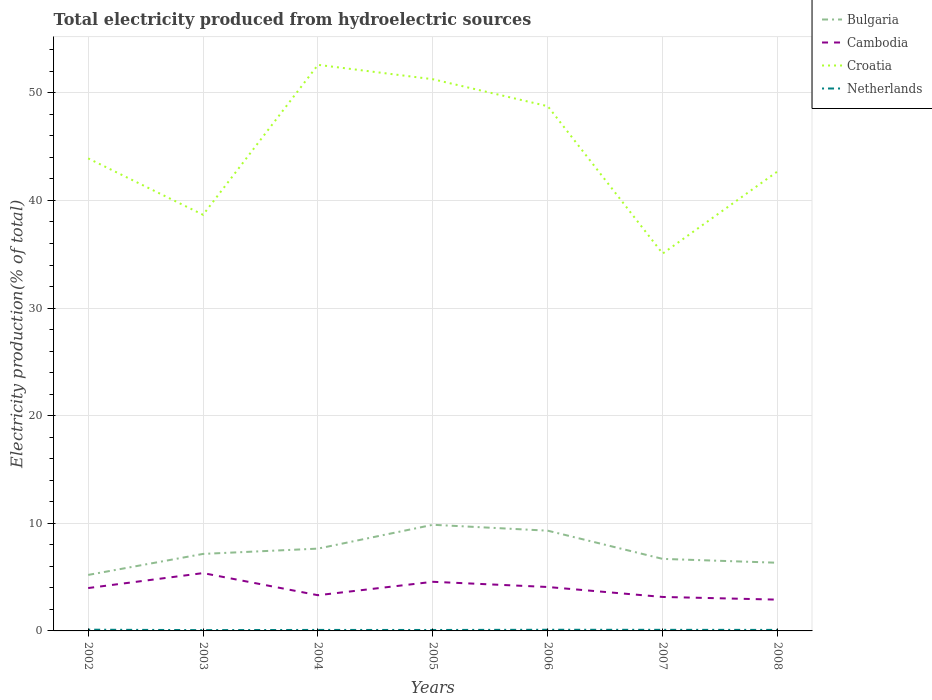How many different coloured lines are there?
Offer a very short reply. 4. Does the line corresponding to Croatia intersect with the line corresponding to Cambodia?
Offer a very short reply. No. Across all years, what is the maximum total electricity produced in Netherlands?
Your answer should be very brief. 0.07. What is the total total electricity produced in Netherlands in the graph?
Provide a short and direct response. 0.01. What is the difference between the highest and the second highest total electricity produced in Bulgaria?
Your answer should be very brief. 4.66. What is the difference between the highest and the lowest total electricity produced in Netherlands?
Make the answer very short. 3. How many lines are there?
Offer a terse response. 4. How many years are there in the graph?
Make the answer very short. 7. Does the graph contain any zero values?
Your response must be concise. No. How many legend labels are there?
Your answer should be compact. 4. What is the title of the graph?
Give a very brief answer. Total electricity produced from hydroelectric sources. What is the label or title of the X-axis?
Give a very brief answer. Years. What is the Electricity production(% of total) in Bulgaria in 2002?
Provide a succinct answer. 5.2. What is the Electricity production(% of total) in Cambodia in 2002?
Offer a terse response. 3.98. What is the Electricity production(% of total) of Croatia in 2002?
Keep it short and to the point. 43.91. What is the Electricity production(% of total) of Netherlands in 2002?
Your answer should be compact. 0.11. What is the Electricity production(% of total) of Bulgaria in 2003?
Your response must be concise. 7.16. What is the Electricity production(% of total) in Cambodia in 2003?
Give a very brief answer. 5.37. What is the Electricity production(% of total) of Croatia in 2003?
Provide a succinct answer. 38.67. What is the Electricity production(% of total) in Netherlands in 2003?
Offer a very short reply. 0.07. What is the Electricity production(% of total) in Bulgaria in 2004?
Offer a very short reply. 7.65. What is the Electricity production(% of total) in Cambodia in 2004?
Your response must be concise. 3.32. What is the Electricity production(% of total) of Croatia in 2004?
Your response must be concise. 52.6. What is the Electricity production(% of total) of Netherlands in 2004?
Ensure brevity in your answer.  0.09. What is the Electricity production(% of total) in Bulgaria in 2005?
Offer a terse response. 9.86. What is the Electricity production(% of total) in Cambodia in 2005?
Offer a terse response. 4.56. What is the Electricity production(% of total) in Croatia in 2005?
Offer a very short reply. 51.26. What is the Electricity production(% of total) in Netherlands in 2005?
Ensure brevity in your answer.  0.09. What is the Electricity production(% of total) in Bulgaria in 2006?
Your response must be concise. 9.31. What is the Electricity production(% of total) of Cambodia in 2006?
Provide a succinct answer. 4.08. What is the Electricity production(% of total) in Croatia in 2006?
Offer a very short reply. 48.76. What is the Electricity production(% of total) of Netherlands in 2006?
Ensure brevity in your answer.  0.11. What is the Electricity production(% of total) in Bulgaria in 2007?
Make the answer very short. 6.69. What is the Electricity production(% of total) in Cambodia in 2007?
Provide a succinct answer. 3.16. What is the Electricity production(% of total) in Croatia in 2007?
Your answer should be compact. 35.06. What is the Electricity production(% of total) of Netherlands in 2007?
Ensure brevity in your answer.  0.1. What is the Electricity production(% of total) of Bulgaria in 2008?
Provide a succinct answer. 6.33. What is the Electricity production(% of total) in Cambodia in 2008?
Your response must be concise. 2.91. What is the Electricity production(% of total) of Croatia in 2008?
Offer a terse response. 42.7. What is the Electricity production(% of total) of Netherlands in 2008?
Give a very brief answer. 0.09. Across all years, what is the maximum Electricity production(% of total) in Bulgaria?
Your response must be concise. 9.86. Across all years, what is the maximum Electricity production(% of total) in Cambodia?
Provide a short and direct response. 5.37. Across all years, what is the maximum Electricity production(% of total) of Croatia?
Ensure brevity in your answer.  52.6. Across all years, what is the maximum Electricity production(% of total) of Netherlands?
Give a very brief answer. 0.11. Across all years, what is the minimum Electricity production(% of total) of Bulgaria?
Ensure brevity in your answer.  5.2. Across all years, what is the minimum Electricity production(% of total) in Cambodia?
Provide a succinct answer. 2.91. Across all years, what is the minimum Electricity production(% of total) in Croatia?
Your answer should be compact. 35.06. Across all years, what is the minimum Electricity production(% of total) of Netherlands?
Make the answer very short. 0.07. What is the total Electricity production(% of total) of Bulgaria in the graph?
Provide a short and direct response. 52.21. What is the total Electricity production(% of total) of Cambodia in the graph?
Your answer should be compact. 27.38. What is the total Electricity production(% of total) of Croatia in the graph?
Offer a terse response. 312.96. What is the total Electricity production(% of total) of Netherlands in the graph?
Your answer should be compact. 0.67. What is the difference between the Electricity production(% of total) of Bulgaria in 2002 and that in 2003?
Provide a short and direct response. -1.95. What is the difference between the Electricity production(% of total) of Cambodia in 2002 and that in 2003?
Offer a terse response. -1.39. What is the difference between the Electricity production(% of total) in Croatia in 2002 and that in 2003?
Make the answer very short. 5.24. What is the difference between the Electricity production(% of total) in Netherlands in 2002 and that in 2003?
Provide a short and direct response. 0.04. What is the difference between the Electricity production(% of total) in Bulgaria in 2002 and that in 2004?
Offer a very short reply. -2.44. What is the difference between the Electricity production(% of total) of Cambodia in 2002 and that in 2004?
Keep it short and to the point. 0.67. What is the difference between the Electricity production(% of total) in Croatia in 2002 and that in 2004?
Ensure brevity in your answer.  -8.69. What is the difference between the Electricity production(% of total) of Netherlands in 2002 and that in 2004?
Keep it short and to the point. 0.02. What is the difference between the Electricity production(% of total) of Bulgaria in 2002 and that in 2005?
Offer a terse response. -4.66. What is the difference between the Electricity production(% of total) in Cambodia in 2002 and that in 2005?
Ensure brevity in your answer.  -0.58. What is the difference between the Electricity production(% of total) of Croatia in 2002 and that in 2005?
Your answer should be compact. -7.36. What is the difference between the Electricity production(% of total) in Netherlands in 2002 and that in 2005?
Make the answer very short. 0.03. What is the difference between the Electricity production(% of total) in Bulgaria in 2002 and that in 2006?
Your answer should be very brief. -4.11. What is the difference between the Electricity production(% of total) in Cambodia in 2002 and that in 2006?
Give a very brief answer. -0.1. What is the difference between the Electricity production(% of total) of Croatia in 2002 and that in 2006?
Provide a succinct answer. -4.85. What is the difference between the Electricity production(% of total) of Netherlands in 2002 and that in 2006?
Keep it short and to the point. 0.01. What is the difference between the Electricity production(% of total) of Bulgaria in 2002 and that in 2007?
Make the answer very short. -1.49. What is the difference between the Electricity production(% of total) of Cambodia in 2002 and that in 2007?
Offer a very short reply. 0.83. What is the difference between the Electricity production(% of total) of Croatia in 2002 and that in 2007?
Your answer should be very brief. 8.84. What is the difference between the Electricity production(% of total) in Netherlands in 2002 and that in 2007?
Give a very brief answer. 0.01. What is the difference between the Electricity production(% of total) in Bulgaria in 2002 and that in 2008?
Your answer should be compact. -1.13. What is the difference between the Electricity production(% of total) of Cambodia in 2002 and that in 2008?
Provide a succinct answer. 1.08. What is the difference between the Electricity production(% of total) of Croatia in 2002 and that in 2008?
Keep it short and to the point. 1.21. What is the difference between the Electricity production(% of total) of Netherlands in 2002 and that in 2008?
Keep it short and to the point. 0.02. What is the difference between the Electricity production(% of total) in Bulgaria in 2003 and that in 2004?
Your answer should be compact. -0.49. What is the difference between the Electricity production(% of total) in Cambodia in 2003 and that in 2004?
Your answer should be very brief. 2.06. What is the difference between the Electricity production(% of total) of Croatia in 2003 and that in 2004?
Offer a terse response. -13.93. What is the difference between the Electricity production(% of total) in Netherlands in 2003 and that in 2004?
Your response must be concise. -0.02. What is the difference between the Electricity production(% of total) in Bulgaria in 2003 and that in 2005?
Make the answer very short. -2.71. What is the difference between the Electricity production(% of total) in Cambodia in 2003 and that in 2005?
Keep it short and to the point. 0.81. What is the difference between the Electricity production(% of total) in Croatia in 2003 and that in 2005?
Provide a succinct answer. -12.6. What is the difference between the Electricity production(% of total) of Netherlands in 2003 and that in 2005?
Your answer should be compact. -0.01. What is the difference between the Electricity production(% of total) in Bulgaria in 2003 and that in 2006?
Provide a succinct answer. -2.16. What is the difference between the Electricity production(% of total) of Cambodia in 2003 and that in 2006?
Your answer should be compact. 1.29. What is the difference between the Electricity production(% of total) of Croatia in 2003 and that in 2006?
Your answer should be very brief. -10.09. What is the difference between the Electricity production(% of total) in Netherlands in 2003 and that in 2006?
Keep it short and to the point. -0.03. What is the difference between the Electricity production(% of total) of Bulgaria in 2003 and that in 2007?
Make the answer very short. 0.46. What is the difference between the Electricity production(% of total) of Cambodia in 2003 and that in 2007?
Provide a succinct answer. 2.22. What is the difference between the Electricity production(% of total) of Croatia in 2003 and that in 2007?
Give a very brief answer. 3.6. What is the difference between the Electricity production(% of total) of Netherlands in 2003 and that in 2007?
Your answer should be very brief. -0.03. What is the difference between the Electricity production(% of total) in Bulgaria in 2003 and that in 2008?
Provide a short and direct response. 0.82. What is the difference between the Electricity production(% of total) of Cambodia in 2003 and that in 2008?
Your response must be concise. 2.47. What is the difference between the Electricity production(% of total) in Croatia in 2003 and that in 2008?
Offer a terse response. -4.03. What is the difference between the Electricity production(% of total) in Netherlands in 2003 and that in 2008?
Give a very brief answer. -0.02. What is the difference between the Electricity production(% of total) in Bulgaria in 2004 and that in 2005?
Your answer should be very brief. -2.22. What is the difference between the Electricity production(% of total) in Cambodia in 2004 and that in 2005?
Your answer should be very brief. -1.25. What is the difference between the Electricity production(% of total) of Croatia in 2004 and that in 2005?
Provide a succinct answer. 1.34. What is the difference between the Electricity production(% of total) in Netherlands in 2004 and that in 2005?
Your answer should be very brief. 0. What is the difference between the Electricity production(% of total) of Bulgaria in 2004 and that in 2006?
Your response must be concise. -1.67. What is the difference between the Electricity production(% of total) in Cambodia in 2004 and that in 2006?
Make the answer very short. -0.76. What is the difference between the Electricity production(% of total) of Croatia in 2004 and that in 2006?
Keep it short and to the point. 3.84. What is the difference between the Electricity production(% of total) of Netherlands in 2004 and that in 2006?
Your answer should be compact. -0.01. What is the difference between the Electricity production(% of total) of Bulgaria in 2004 and that in 2007?
Provide a short and direct response. 0.95. What is the difference between the Electricity production(% of total) in Cambodia in 2004 and that in 2007?
Offer a terse response. 0.16. What is the difference between the Electricity production(% of total) of Croatia in 2004 and that in 2007?
Keep it short and to the point. 17.54. What is the difference between the Electricity production(% of total) in Netherlands in 2004 and that in 2007?
Your answer should be compact. -0.01. What is the difference between the Electricity production(% of total) in Bulgaria in 2004 and that in 2008?
Ensure brevity in your answer.  1.31. What is the difference between the Electricity production(% of total) of Cambodia in 2004 and that in 2008?
Provide a short and direct response. 0.41. What is the difference between the Electricity production(% of total) of Croatia in 2004 and that in 2008?
Provide a succinct answer. 9.9. What is the difference between the Electricity production(% of total) in Netherlands in 2004 and that in 2008?
Your response must be concise. -0. What is the difference between the Electricity production(% of total) of Bulgaria in 2005 and that in 2006?
Make the answer very short. 0.55. What is the difference between the Electricity production(% of total) in Cambodia in 2005 and that in 2006?
Your response must be concise. 0.48. What is the difference between the Electricity production(% of total) in Croatia in 2005 and that in 2006?
Give a very brief answer. 2.51. What is the difference between the Electricity production(% of total) in Netherlands in 2005 and that in 2006?
Keep it short and to the point. -0.02. What is the difference between the Electricity production(% of total) of Bulgaria in 2005 and that in 2007?
Your answer should be compact. 3.17. What is the difference between the Electricity production(% of total) in Cambodia in 2005 and that in 2007?
Your answer should be very brief. 1.41. What is the difference between the Electricity production(% of total) of Croatia in 2005 and that in 2007?
Your answer should be compact. 16.2. What is the difference between the Electricity production(% of total) in Netherlands in 2005 and that in 2007?
Give a very brief answer. -0.01. What is the difference between the Electricity production(% of total) in Bulgaria in 2005 and that in 2008?
Give a very brief answer. 3.53. What is the difference between the Electricity production(% of total) in Cambodia in 2005 and that in 2008?
Your answer should be compact. 1.66. What is the difference between the Electricity production(% of total) of Croatia in 2005 and that in 2008?
Make the answer very short. 8.56. What is the difference between the Electricity production(% of total) in Netherlands in 2005 and that in 2008?
Ensure brevity in your answer.  -0.01. What is the difference between the Electricity production(% of total) in Bulgaria in 2006 and that in 2007?
Offer a terse response. 2.62. What is the difference between the Electricity production(% of total) in Cambodia in 2006 and that in 2007?
Ensure brevity in your answer.  0.93. What is the difference between the Electricity production(% of total) in Croatia in 2006 and that in 2007?
Offer a terse response. 13.69. What is the difference between the Electricity production(% of total) of Netherlands in 2006 and that in 2007?
Offer a terse response. 0.01. What is the difference between the Electricity production(% of total) in Bulgaria in 2006 and that in 2008?
Offer a very short reply. 2.98. What is the difference between the Electricity production(% of total) in Cambodia in 2006 and that in 2008?
Offer a terse response. 1.17. What is the difference between the Electricity production(% of total) of Croatia in 2006 and that in 2008?
Provide a succinct answer. 6.06. What is the difference between the Electricity production(% of total) in Netherlands in 2006 and that in 2008?
Provide a short and direct response. 0.01. What is the difference between the Electricity production(% of total) in Bulgaria in 2007 and that in 2008?
Make the answer very short. 0.36. What is the difference between the Electricity production(% of total) in Cambodia in 2007 and that in 2008?
Your response must be concise. 0.25. What is the difference between the Electricity production(% of total) of Croatia in 2007 and that in 2008?
Keep it short and to the point. -7.63. What is the difference between the Electricity production(% of total) of Netherlands in 2007 and that in 2008?
Offer a very short reply. 0.01. What is the difference between the Electricity production(% of total) of Bulgaria in 2002 and the Electricity production(% of total) of Cambodia in 2003?
Your response must be concise. -0.17. What is the difference between the Electricity production(% of total) of Bulgaria in 2002 and the Electricity production(% of total) of Croatia in 2003?
Offer a very short reply. -33.46. What is the difference between the Electricity production(% of total) of Bulgaria in 2002 and the Electricity production(% of total) of Netherlands in 2003?
Your answer should be very brief. 5.13. What is the difference between the Electricity production(% of total) of Cambodia in 2002 and the Electricity production(% of total) of Croatia in 2003?
Ensure brevity in your answer.  -34.68. What is the difference between the Electricity production(% of total) in Cambodia in 2002 and the Electricity production(% of total) in Netherlands in 2003?
Make the answer very short. 3.91. What is the difference between the Electricity production(% of total) of Croatia in 2002 and the Electricity production(% of total) of Netherlands in 2003?
Keep it short and to the point. 43.83. What is the difference between the Electricity production(% of total) in Bulgaria in 2002 and the Electricity production(% of total) in Cambodia in 2004?
Give a very brief answer. 1.89. What is the difference between the Electricity production(% of total) of Bulgaria in 2002 and the Electricity production(% of total) of Croatia in 2004?
Your response must be concise. -47.4. What is the difference between the Electricity production(% of total) in Bulgaria in 2002 and the Electricity production(% of total) in Netherlands in 2004?
Offer a terse response. 5.11. What is the difference between the Electricity production(% of total) in Cambodia in 2002 and the Electricity production(% of total) in Croatia in 2004?
Provide a succinct answer. -48.62. What is the difference between the Electricity production(% of total) in Cambodia in 2002 and the Electricity production(% of total) in Netherlands in 2004?
Offer a very short reply. 3.89. What is the difference between the Electricity production(% of total) in Croatia in 2002 and the Electricity production(% of total) in Netherlands in 2004?
Your answer should be compact. 43.81. What is the difference between the Electricity production(% of total) in Bulgaria in 2002 and the Electricity production(% of total) in Cambodia in 2005?
Your response must be concise. 0.64. What is the difference between the Electricity production(% of total) of Bulgaria in 2002 and the Electricity production(% of total) of Croatia in 2005?
Offer a very short reply. -46.06. What is the difference between the Electricity production(% of total) in Bulgaria in 2002 and the Electricity production(% of total) in Netherlands in 2005?
Your answer should be very brief. 5.12. What is the difference between the Electricity production(% of total) in Cambodia in 2002 and the Electricity production(% of total) in Croatia in 2005?
Give a very brief answer. -47.28. What is the difference between the Electricity production(% of total) in Cambodia in 2002 and the Electricity production(% of total) in Netherlands in 2005?
Provide a short and direct response. 3.9. What is the difference between the Electricity production(% of total) of Croatia in 2002 and the Electricity production(% of total) of Netherlands in 2005?
Ensure brevity in your answer.  43.82. What is the difference between the Electricity production(% of total) of Bulgaria in 2002 and the Electricity production(% of total) of Cambodia in 2006?
Ensure brevity in your answer.  1.12. What is the difference between the Electricity production(% of total) in Bulgaria in 2002 and the Electricity production(% of total) in Croatia in 2006?
Your answer should be very brief. -43.55. What is the difference between the Electricity production(% of total) of Bulgaria in 2002 and the Electricity production(% of total) of Netherlands in 2006?
Make the answer very short. 5.1. What is the difference between the Electricity production(% of total) of Cambodia in 2002 and the Electricity production(% of total) of Croatia in 2006?
Your response must be concise. -44.77. What is the difference between the Electricity production(% of total) in Cambodia in 2002 and the Electricity production(% of total) in Netherlands in 2006?
Your answer should be very brief. 3.88. What is the difference between the Electricity production(% of total) in Croatia in 2002 and the Electricity production(% of total) in Netherlands in 2006?
Your answer should be compact. 43.8. What is the difference between the Electricity production(% of total) of Bulgaria in 2002 and the Electricity production(% of total) of Cambodia in 2007?
Your response must be concise. 2.05. What is the difference between the Electricity production(% of total) in Bulgaria in 2002 and the Electricity production(% of total) in Croatia in 2007?
Provide a succinct answer. -29.86. What is the difference between the Electricity production(% of total) of Bulgaria in 2002 and the Electricity production(% of total) of Netherlands in 2007?
Your answer should be very brief. 5.1. What is the difference between the Electricity production(% of total) of Cambodia in 2002 and the Electricity production(% of total) of Croatia in 2007?
Make the answer very short. -31.08. What is the difference between the Electricity production(% of total) in Cambodia in 2002 and the Electricity production(% of total) in Netherlands in 2007?
Your answer should be very brief. 3.88. What is the difference between the Electricity production(% of total) in Croatia in 2002 and the Electricity production(% of total) in Netherlands in 2007?
Your answer should be very brief. 43.81. What is the difference between the Electricity production(% of total) in Bulgaria in 2002 and the Electricity production(% of total) in Cambodia in 2008?
Ensure brevity in your answer.  2.3. What is the difference between the Electricity production(% of total) in Bulgaria in 2002 and the Electricity production(% of total) in Croatia in 2008?
Your answer should be very brief. -37.5. What is the difference between the Electricity production(% of total) in Bulgaria in 2002 and the Electricity production(% of total) in Netherlands in 2008?
Make the answer very short. 5.11. What is the difference between the Electricity production(% of total) in Cambodia in 2002 and the Electricity production(% of total) in Croatia in 2008?
Offer a terse response. -38.71. What is the difference between the Electricity production(% of total) of Cambodia in 2002 and the Electricity production(% of total) of Netherlands in 2008?
Offer a very short reply. 3.89. What is the difference between the Electricity production(% of total) in Croatia in 2002 and the Electricity production(% of total) in Netherlands in 2008?
Give a very brief answer. 43.81. What is the difference between the Electricity production(% of total) in Bulgaria in 2003 and the Electricity production(% of total) in Cambodia in 2004?
Offer a terse response. 3.84. What is the difference between the Electricity production(% of total) in Bulgaria in 2003 and the Electricity production(% of total) in Croatia in 2004?
Provide a short and direct response. -45.44. What is the difference between the Electricity production(% of total) in Bulgaria in 2003 and the Electricity production(% of total) in Netherlands in 2004?
Keep it short and to the point. 7.06. What is the difference between the Electricity production(% of total) in Cambodia in 2003 and the Electricity production(% of total) in Croatia in 2004?
Provide a short and direct response. -47.23. What is the difference between the Electricity production(% of total) of Cambodia in 2003 and the Electricity production(% of total) of Netherlands in 2004?
Make the answer very short. 5.28. What is the difference between the Electricity production(% of total) of Croatia in 2003 and the Electricity production(% of total) of Netherlands in 2004?
Ensure brevity in your answer.  38.58. What is the difference between the Electricity production(% of total) in Bulgaria in 2003 and the Electricity production(% of total) in Cambodia in 2005?
Make the answer very short. 2.59. What is the difference between the Electricity production(% of total) in Bulgaria in 2003 and the Electricity production(% of total) in Croatia in 2005?
Your answer should be very brief. -44.11. What is the difference between the Electricity production(% of total) in Bulgaria in 2003 and the Electricity production(% of total) in Netherlands in 2005?
Give a very brief answer. 7.07. What is the difference between the Electricity production(% of total) of Cambodia in 2003 and the Electricity production(% of total) of Croatia in 2005?
Ensure brevity in your answer.  -45.89. What is the difference between the Electricity production(% of total) of Cambodia in 2003 and the Electricity production(% of total) of Netherlands in 2005?
Ensure brevity in your answer.  5.29. What is the difference between the Electricity production(% of total) of Croatia in 2003 and the Electricity production(% of total) of Netherlands in 2005?
Your answer should be very brief. 38.58. What is the difference between the Electricity production(% of total) of Bulgaria in 2003 and the Electricity production(% of total) of Cambodia in 2006?
Ensure brevity in your answer.  3.07. What is the difference between the Electricity production(% of total) of Bulgaria in 2003 and the Electricity production(% of total) of Croatia in 2006?
Keep it short and to the point. -41.6. What is the difference between the Electricity production(% of total) of Bulgaria in 2003 and the Electricity production(% of total) of Netherlands in 2006?
Keep it short and to the point. 7.05. What is the difference between the Electricity production(% of total) in Cambodia in 2003 and the Electricity production(% of total) in Croatia in 2006?
Give a very brief answer. -43.38. What is the difference between the Electricity production(% of total) of Cambodia in 2003 and the Electricity production(% of total) of Netherlands in 2006?
Offer a terse response. 5.27. What is the difference between the Electricity production(% of total) in Croatia in 2003 and the Electricity production(% of total) in Netherlands in 2006?
Your answer should be very brief. 38.56. What is the difference between the Electricity production(% of total) in Bulgaria in 2003 and the Electricity production(% of total) in Cambodia in 2007?
Your answer should be compact. 4. What is the difference between the Electricity production(% of total) of Bulgaria in 2003 and the Electricity production(% of total) of Croatia in 2007?
Your answer should be compact. -27.91. What is the difference between the Electricity production(% of total) in Bulgaria in 2003 and the Electricity production(% of total) in Netherlands in 2007?
Offer a very short reply. 7.05. What is the difference between the Electricity production(% of total) in Cambodia in 2003 and the Electricity production(% of total) in Croatia in 2007?
Provide a short and direct response. -29.69. What is the difference between the Electricity production(% of total) in Cambodia in 2003 and the Electricity production(% of total) in Netherlands in 2007?
Keep it short and to the point. 5.27. What is the difference between the Electricity production(% of total) of Croatia in 2003 and the Electricity production(% of total) of Netherlands in 2007?
Provide a short and direct response. 38.57. What is the difference between the Electricity production(% of total) in Bulgaria in 2003 and the Electricity production(% of total) in Cambodia in 2008?
Keep it short and to the point. 4.25. What is the difference between the Electricity production(% of total) in Bulgaria in 2003 and the Electricity production(% of total) in Croatia in 2008?
Ensure brevity in your answer.  -35.54. What is the difference between the Electricity production(% of total) of Bulgaria in 2003 and the Electricity production(% of total) of Netherlands in 2008?
Give a very brief answer. 7.06. What is the difference between the Electricity production(% of total) in Cambodia in 2003 and the Electricity production(% of total) in Croatia in 2008?
Your answer should be compact. -37.32. What is the difference between the Electricity production(% of total) of Cambodia in 2003 and the Electricity production(% of total) of Netherlands in 2008?
Keep it short and to the point. 5.28. What is the difference between the Electricity production(% of total) of Croatia in 2003 and the Electricity production(% of total) of Netherlands in 2008?
Provide a succinct answer. 38.57. What is the difference between the Electricity production(% of total) in Bulgaria in 2004 and the Electricity production(% of total) in Cambodia in 2005?
Offer a terse response. 3.08. What is the difference between the Electricity production(% of total) in Bulgaria in 2004 and the Electricity production(% of total) in Croatia in 2005?
Your response must be concise. -43.62. What is the difference between the Electricity production(% of total) in Bulgaria in 2004 and the Electricity production(% of total) in Netherlands in 2005?
Your answer should be very brief. 7.56. What is the difference between the Electricity production(% of total) of Cambodia in 2004 and the Electricity production(% of total) of Croatia in 2005?
Give a very brief answer. -47.95. What is the difference between the Electricity production(% of total) in Cambodia in 2004 and the Electricity production(% of total) in Netherlands in 2005?
Keep it short and to the point. 3.23. What is the difference between the Electricity production(% of total) of Croatia in 2004 and the Electricity production(% of total) of Netherlands in 2005?
Your answer should be compact. 52.51. What is the difference between the Electricity production(% of total) in Bulgaria in 2004 and the Electricity production(% of total) in Cambodia in 2006?
Provide a succinct answer. 3.57. What is the difference between the Electricity production(% of total) in Bulgaria in 2004 and the Electricity production(% of total) in Croatia in 2006?
Offer a very short reply. -41.11. What is the difference between the Electricity production(% of total) in Bulgaria in 2004 and the Electricity production(% of total) in Netherlands in 2006?
Make the answer very short. 7.54. What is the difference between the Electricity production(% of total) of Cambodia in 2004 and the Electricity production(% of total) of Croatia in 2006?
Offer a very short reply. -45.44. What is the difference between the Electricity production(% of total) of Cambodia in 2004 and the Electricity production(% of total) of Netherlands in 2006?
Ensure brevity in your answer.  3.21. What is the difference between the Electricity production(% of total) in Croatia in 2004 and the Electricity production(% of total) in Netherlands in 2006?
Your response must be concise. 52.49. What is the difference between the Electricity production(% of total) in Bulgaria in 2004 and the Electricity production(% of total) in Cambodia in 2007?
Provide a short and direct response. 4.49. What is the difference between the Electricity production(% of total) of Bulgaria in 2004 and the Electricity production(% of total) of Croatia in 2007?
Ensure brevity in your answer.  -27.42. What is the difference between the Electricity production(% of total) in Bulgaria in 2004 and the Electricity production(% of total) in Netherlands in 2007?
Ensure brevity in your answer.  7.55. What is the difference between the Electricity production(% of total) of Cambodia in 2004 and the Electricity production(% of total) of Croatia in 2007?
Offer a terse response. -31.75. What is the difference between the Electricity production(% of total) of Cambodia in 2004 and the Electricity production(% of total) of Netherlands in 2007?
Give a very brief answer. 3.22. What is the difference between the Electricity production(% of total) of Croatia in 2004 and the Electricity production(% of total) of Netherlands in 2007?
Offer a very short reply. 52.5. What is the difference between the Electricity production(% of total) in Bulgaria in 2004 and the Electricity production(% of total) in Cambodia in 2008?
Your answer should be compact. 4.74. What is the difference between the Electricity production(% of total) of Bulgaria in 2004 and the Electricity production(% of total) of Croatia in 2008?
Offer a terse response. -35.05. What is the difference between the Electricity production(% of total) of Bulgaria in 2004 and the Electricity production(% of total) of Netherlands in 2008?
Your answer should be very brief. 7.55. What is the difference between the Electricity production(% of total) in Cambodia in 2004 and the Electricity production(% of total) in Croatia in 2008?
Ensure brevity in your answer.  -39.38. What is the difference between the Electricity production(% of total) of Cambodia in 2004 and the Electricity production(% of total) of Netherlands in 2008?
Your answer should be compact. 3.22. What is the difference between the Electricity production(% of total) in Croatia in 2004 and the Electricity production(% of total) in Netherlands in 2008?
Your answer should be compact. 52.51. What is the difference between the Electricity production(% of total) in Bulgaria in 2005 and the Electricity production(% of total) in Cambodia in 2006?
Make the answer very short. 5.78. What is the difference between the Electricity production(% of total) in Bulgaria in 2005 and the Electricity production(% of total) in Croatia in 2006?
Your answer should be compact. -38.89. What is the difference between the Electricity production(% of total) in Bulgaria in 2005 and the Electricity production(% of total) in Netherlands in 2006?
Give a very brief answer. 9.76. What is the difference between the Electricity production(% of total) in Cambodia in 2005 and the Electricity production(% of total) in Croatia in 2006?
Ensure brevity in your answer.  -44.19. What is the difference between the Electricity production(% of total) of Cambodia in 2005 and the Electricity production(% of total) of Netherlands in 2006?
Your response must be concise. 4.46. What is the difference between the Electricity production(% of total) in Croatia in 2005 and the Electricity production(% of total) in Netherlands in 2006?
Offer a terse response. 51.16. What is the difference between the Electricity production(% of total) in Bulgaria in 2005 and the Electricity production(% of total) in Cambodia in 2007?
Offer a terse response. 6.71. What is the difference between the Electricity production(% of total) in Bulgaria in 2005 and the Electricity production(% of total) in Croatia in 2007?
Your answer should be very brief. -25.2. What is the difference between the Electricity production(% of total) of Bulgaria in 2005 and the Electricity production(% of total) of Netherlands in 2007?
Ensure brevity in your answer.  9.76. What is the difference between the Electricity production(% of total) in Cambodia in 2005 and the Electricity production(% of total) in Croatia in 2007?
Provide a succinct answer. -30.5. What is the difference between the Electricity production(% of total) of Cambodia in 2005 and the Electricity production(% of total) of Netherlands in 2007?
Offer a terse response. 4.46. What is the difference between the Electricity production(% of total) of Croatia in 2005 and the Electricity production(% of total) of Netherlands in 2007?
Provide a succinct answer. 51.16. What is the difference between the Electricity production(% of total) of Bulgaria in 2005 and the Electricity production(% of total) of Cambodia in 2008?
Your response must be concise. 6.96. What is the difference between the Electricity production(% of total) in Bulgaria in 2005 and the Electricity production(% of total) in Croatia in 2008?
Offer a terse response. -32.84. What is the difference between the Electricity production(% of total) of Bulgaria in 2005 and the Electricity production(% of total) of Netherlands in 2008?
Make the answer very short. 9.77. What is the difference between the Electricity production(% of total) of Cambodia in 2005 and the Electricity production(% of total) of Croatia in 2008?
Provide a succinct answer. -38.13. What is the difference between the Electricity production(% of total) of Cambodia in 2005 and the Electricity production(% of total) of Netherlands in 2008?
Make the answer very short. 4.47. What is the difference between the Electricity production(% of total) in Croatia in 2005 and the Electricity production(% of total) in Netherlands in 2008?
Your response must be concise. 51.17. What is the difference between the Electricity production(% of total) of Bulgaria in 2006 and the Electricity production(% of total) of Cambodia in 2007?
Give a very brief answer. 6.16. What is the difference between the Electricity production(% of total) of Bulgaria in 2006 and the Electricity production(% of total) of Croatia in 2007?
Give a very brief answer. -25.75. What is the difference between the Electricity production(% of total) of Bulgaria in 2006 and the Electricity production(% of total) of Netherlands in 2007?
Your answer should be very brief. 9.21. What is the difference between the Electricity production(% of total) in Cambodia in 2006 and the Electricity production(% of total) in Croatia in 2007?
Keep it short and to the point. -30.98. What is the difference between the Electricity production(% of total) in Cambodia in 2006 and the Electricity production(% of total) in Netherlands in 2007?
Offer a very short reply. 3.98. What is the difference between the Electricity production(% of total) of Croatia in 2006 and the Electricity production(% of total) of Netherlands in 2007?
Provide a succinct answer. 48.66. What is the difference between the Electricity production(% of total) of Bulgaria in 2006 and the Electricity production(% of total) of Cambodia in 2008?
Make the answer very short. 6.41. What is the difference between the Electricity production(% of total) in Bulgaria in 2006 and the Electricity production(% of total) in Croatia in 2008?
Your answer should be compact. -33.38. What is the difference between the Electricity production(% of total) of Bulgaria in 2006 and the Electricity production(% of total) of Netherlands in 2008?
Your answer should be very brief. 9.22. What is the difference between the Electricity production(% of total) of Cambodia in 2006 and the Electricity production(% of total) of Croatia in 2008?
Give a very brief answer. -38.62. What is the difference between the Electricity production(% of total) of Cambodia in 2006 and the Electricity production(% of total) of Netherlands in 2008?
Offer a very short reply. 3.99. What is the difference between the Electricity production(% of total) in Croatia in 2006 and the Electricity production(% of total) in Netherlands in 2008?
Offer a terse response. 48.66. What is the difference between the Electricity production(% of total) of Bulgaria in 2007 and the Electricity production(% of total) of Cambodia in 2008?
Your answer should be compact. 3.79. What is the difference between the Electricity production(% of total) in Bulgaria in 2007 and the Electricity production(% of total) in Croatia in 2008?
Keep it short and to the point. -36. What is the difference between the Electricity production(% of total) of Bulgaria in 2007 and the Electricity production(% of total) of Netherlands in 2008?
Offer a very short reply. 6.6. What is the difference between the Electricity production(% of total) of Cambodia in 2007 and the Electricity production(% of total) of Croatia in 2008?
Give a very brief answer. -39.54. What is the difference between the Electricity production(% of total) in Cambodia in 2007 and the Electricity production(% of total) in Netherlands in 2008?
Your response must be concise. 3.06. What is the difference between the Electricity production(% of total) of Croatia in 2007 and the Electricity production(% of total) of Netherlands in 2008?
Keep it short and to the point. 34.97. What is the average Electricity production(% of total) in Bulgaria per year?
Provide a short and direct response. 7.46. What is the average Electricity production(% of total) of Cambodia per year?
Provide a succinct answer. 3.91. What is the average Electricity production(% of total) in Croatia per year?
Make the answer very short. 44.71. What is the average Electricity production(% of total) in Netherlands per year?
Ensure brevity in your answer.  0.1. In the year 2002, what is the difference between the Electricity production(% of total) in Bulgaria and Electricity production(% of total) in Cambodia?
Ensure brevity in your answer.  1.22. In the year 2002, what is the difference between the Electricity production(% of total) in Bulgaria and Electricity production(% of total) in Croatia?
Your answer should be very brief. -38.7. In the year 2002, what is the difference between the Electricity production(% of total) in Bulgaria and Electricity production(% of total) in Netherlands?
Offer a very short reply. 5.09. In the year 2002, what is the difference between the Electricity production(% of total) of Cambodia and Electricity production(% of total) of Croatia?
Provide a short and direct response. -39.92. In the year 2002, what is the difference between the Electricity production(% of total) of Cambodia and Electricity production(% of total) of Netherlands?
Your answer should be very brief. 3.87. In the year 2002, what is the difference between the Electricity production(% of total) in Croatia and Electricity production(% of total) in Netherlands?
Provide a short and direct response. 43.79. In the year 2003, what is the difference between the Electricity production(% of total) in Bulgaria and Electricity production(% of total) in Cambodia?
Ensure brevity in your answer.  1.78. In the year 2003, what is the difference between the Electricity production(% of total) in Bulgaria and Electricity production(% of total) in Croatia?
Provide a succinct answer. -31.51. In the year 2003, what is the difference between the Electricity production(% of total) in Bulgaria and Electricity production(% of total) in Netherlands?
Your response must be concise. 7.08. In the year 2003, what is the difference between the Electricity production(% of total) in Cambodia and Electricity production(% of total) in Croatia?
Make the answer very short. -33.29. In the year 2003, what is the difference between the Electricity production(% of total) of Cambodia and Electricity production(% of total) of Netherlands?
Offer a very short reply. 5.3. In the year 2003, what is the difference between the Electricity production(% of total) of Croatia and Electricity production(% of total) of Netherlands?
Your answer should be compact. 38.59. In the year 2004, what is the difference between the Electricity production(% of total) in Bulgaria and Electricity production(% of total) in Cambodia?
Your answer should be compact. 4.33. In the year 2004, what is the difference between the Electricity production(% of total) of Bulgaria and Electricity production(% of total) of Croatia?
Provide a short and direct response. -44.95. In the year 2004, what is the difference between the Electricity production(% of total) of Bulgaria and Electricity production(% of total) of Netherlands?
Your answer should be very brief. 7.55. In the year 2004, what is the difference between the Electricity production(% of total) in Cambodia and Electricity production(% of total) in Croatia?
Provide a succinct answer. -49.28. In the year 2004, what is the difference between the Electricity production(% of total) of Cambodia and Electricity production(% of total) of Netherlands?
Your answer should be very brief. 3.22. In the year 2004, what is the difference between the Electricity production(% of total) of Croatia and Electricity production(% of total) of Netherlands?
Offer a terse response. 52.51. In the year 2005, what is the difference between the Electricity production(% of total) of Bulgaria and Electricity production(% of total) of Cambodia?
Your answer should be compact. 5.3. In the year 2005, what is the difference between the Electricity production(% of total) of Bulgaria and Electricity production(% of total) of Croatia?
Your answer should be very brief. -41.4. In the year 2005, what is the difference between the Electricity production(% of total) in Bulgaria and Electricity production(% of total) in Netherlands?
Give a very brief answer. 9.78. In the year 2005, what is the difference between the Electricity production(% of total) in Cambodia and Electricity production(% of total) in Croatia?
Provide a succinct answer. -46.7. In the year 2005, what is the difference between the Electricity production(% of total) of Cambodia and Electricity production(% of total) of Netherlands?
Give a very brief answer. 4.48. In the year 2005, what is the difference between the Electricity production(% of total) of Croatia and Electricity production(% of total) of Netherlands?
Provide a short and direct response. 51.17. In the year 2006, what is the difference between the Electricity production(% of total) in Bulgaria and Electricity production(% of total) in Cambodia?
Make the answer very short. 5.23. In the year 2006, what is the difference between the Electricity production(% of total) in Bulgaria and Electricity production(% of total) in Croatia?
Provide a succinct answer. -39.44. In the year 2006, what is the difference between the Electricity production(% of total) of Bulgaria and Electricity production(% of total) of Netherlands?
Make the answer very short. 9.21. In the year 2006, what is the difference between the Electricity production(% of total) of Cambodia and Electricity production(% of total) of Croatia?
Give a very brief answer. -44.68. In the year 2006, what is the difference between the Electricity production(% of total) in Cambodia and Electricity production(% of total) in Netherlands?
Provide a succinct answer. 3.97. In the year 2006, what is the difference between the Electricity production(% of total) of Croatia and Electricity production(% of total) of Netherlands?
Make the answer very short. 48.65. In the year 2007, what is the difference between the Electricity production(% of total) in Bulgaria and Electricity production(% of total) in Cambodia?
Your answer should be very brief. 3.54. In the year 2007, what is the difference between the Electricity production(% of total) in Bulgaria and Electricity production(% of total) in Croatia?
Give a very brief answer. -28.37. In the year 2007, what is the difference between the Electricity production(% of total) of Bulgaria and Electricity production(% of total) of Netherlands?
Keep it short and to the point. 6.59. In the year 2007, what is the difference between the Electricity production(% of total) of Cambodia and Electricity production(% of total) of Croatia?
Your response must be concise. -31.91. In the year 2007, what is the difference between the Electricity production(% of total) of Cambodia and Electricity production(% of total) of Netherlands?
Provide a short and direct response. 3.05. In the year 2007, what is the difference between the Electricity production(% of total) in Croatia and Electricity production(% of total) in Netherlands?
Provide a short and direct response. 34.96. In the year 2008, what is the difference between the Electricity production(% of total) in Bulgaria and Electricity production(% of total) in Cambodia?
Provide a short and direct response. 3.43. In the year 2008, what is the difference between the Electricity production(% of total) in Bulgaria and Electricity production(% of total) in Croatia?
Offer a terse response. -36.36. In the year 2008, what is the difference between the Electricity production(% of total) of Bulgaria and Electricity production(% of total) of Netherlands?
Keep it short and to the point. 6.24. In the year 2008, what is the difference between the Electricity production(% of total) of Cambodia and Electricity production(% of total) of Croatia?
Your response must be concise. -39.79. In the year 2008, what is the difference between the Electricity production(% of total) of Cambodia and Electricity production(% of total) of Netherlands?
Give a very brief answer. 2.81. In the year 2008, what is the difference between the Electricity production(% of total) of Croatia and Electricity production(% of total) of Netherlands?
Make the answer very short. 42.6. What is the ratio of the Electricity production(% of total) in Bulgaria in 2002 to that in 2003?
Your response must be concise. 0.73. What is the ratio of the Electricity production(% of total) of Cambodia in 2002 to that in 2003?
Offer a terse response. 0.74. What is the ratio of the Electricity production(% of total) in Croatia in 2002 to that in 2003?
Your answer should be compact. 1.14. What is the ratio of the Electricity production(% of total) of Netherlands in 2002 to that in 2003?
Provide a succinct answer. 1.54. What is the ratio of the Electricity production(% of total) of Bulgaria in 2002 to that in 2004?
Give a very brief answer. 0.68. What is the ratio of the Electricity production(% of total) in Cambodia in 2002 to that in 2004?
Offer a terse response. 1.2. What is the ratio of the Electricity production(% of total) of Croatia in 2002 to that in 2004?
Keep it short and to the point. 0.83. What is the ratio of the Electricity production(% of total) in Netherlands in 2002 to that in 2004?
Your response must be concise. 1.24. What is the ratio of the Electricity production(% of total) of Bulgaria in 2002 to that in 2005?
Ensure brevity in your answer.  0.53. What is the ratio of the Electricity production(% of total) in Cambodia in 2002 to that in 2005?
Provide a short and direct response. 0.87. What is the ratio of the Electricity production(% of total) in Croatia in 2002 to that in 2005?
Give a very brief answer. 0.86. What is the ratio of the Electricity production(% of total) in Netherlands in 2002 to that in 2005?
Keep it short and to the point. 1.31. What is the ratio of the Electricity production(% of total) in Bulgaria in 2002 to that in 2006?
Keep it short and to the point. 0.56. What is the ratio of the Electricity production(% of total) in Cambodia in 2002 to that in 2006?
Offer a terse response. 0.98. What is the ratio of the Electricity production(% of total) of Croatia in 2002 to that in 2006?
Give a very brief answer. 0.9. What is the ratio of the Electricity production(% of total) in Netherlands in 2002 to that in 2006?
Make the answer very short. 1.06. What is the ratio of the Electricity production(% of total) in Bulgaria in 2002 to that in 2007?
Your answer should be compact. 0.78. What is the ratio of the Electricity production(% of total) of Cambodia in 2002 to that in 2007?
Provide a succinct answer. 1.26. What is the ratio of the Electricity production(% of total) in Croatia in 2002 to that in 2007?
Provide a short and direct response. 1.25. What is the ratio of the Electricity production(% of total) of Netherlands in 2002 to that in 2007?
Offer a terse response. 1.13. What is the ratio of the Electricity production(% of total) in Bulgaria in 2002 to that in 2008?
Provide a succinct answer. 0.82. What is the ratio of the Electricity production(% of total) of Cambodia in 2002 to that in 2008?
Keep it short and to the point. 1.37. What is the ratio of the Electricity production(% of total) in Croatia in 2002 to that in 2008?
Offer a terse response. 1.03. What is the ratio of the Electricity production(% of total) of Netherlands in 2002 to that in 2008?
Keep it short and to the point. 1.21. What is the ratio of the Electricity production(% of total) of Bulgaria in 2003 to that in 2004?
Keep it short and to the point. 0.94. What is the ratio of the Electricity production(% of total) of Cambodia in 2003 to that in 2004?
Keep it short and to the point. 1.62. What is the ratio of the Electricity production(% of total) in Croatia in 2003 to that in 2004?
Keep it short and to the point. 0.74. What is the ratio of the Electricity production(% of total) of Netherlands in 2003 to that in 2004?
Ensure brevity in your answer.  0.8. What is the ratio of the Electricity production(% of total) of Bulgaria in 2003 to that in 2005?
Your answer should be very brief. 0.73. What is the ratio of the Electricity production(% of total) of Cambodia in 2003 to that in 2005?
Give a very brief answer. 1.18. What is the ratio of the Electricity production(% of total) of Croatia in 2003 to that in 2005?
Make the answer very short. 0.75. What is the ratio of the Electricity production(% of total) in Netherlands in 2003 to that in 2005?
Keep it short and to the point. 0.85. What is the ratio of the Electricity production(% of total) in Bulgaria in 2003 to that in 2006?
Your response must be concise. 0.77. What is the ratio of the Electricity production(% of total) in Cambodia in 2003 to that in 2006?
Provide a short and direct response. 1.32. What is the ratio of the Electricity production(% of total) in Croatia in 2003 to that in 2006?
Offer a terse response. 0.79. What is the ratio of the Electricity production(% of total) of Netherlands in 2003 to that in 2006?
Make the answer very short. 0.69. What is the ratio of the Electricity production(% of total) of Bulgaria in 2003 to that in 2007?
Provide a succinct answer. 1.07. What is the ratio of the Electricity production(% of total) of Cambodia in 2003 to that in 2007?
Your answer should be very brief. 1.7. What is the ratio of the Electricity production(% of total) of Croatia in 2003 to that in 2007?
Make the answer very short. 1.1. What is the ratio of the Electricity production(% of total) in Netherlands in 2003 to that in 2007?
Your answer should be very brief. 0.73. What is the ratio of the Electricity production(% of total) in Bulgaria in 2003 to that in 2008?
Provide a short and direct response. 1.13. What is the ratio of the Electricity production(% of total) of Cambodia in 2003 to that in 2008?
Your answer should be compact. 1.85. What is the ratio of the Electricity production(% of total) in Croatia in 2003 to that in 2008?
Keep it short and to the point. 0.91. What is the ratio of the Electricity production(% of total) in Netherlands in 2003 to that in 2008?
Ensure brevity in your answer.  0.78. What is the ratio of the Electricity production(% of total) of Bulgaria in 2004 to that in 2005?
Ensure brevity in your answer.  0.78. What is the ratio of the Electricity production(% of total) of Cambodia in 2004 to that in 2005?
Keep it short and to the point. 0.73. What is the ratio of the Electricity production(% of total) in Croatia in 2004 to that in 2005?
Your response must be concise. 1.03. What is the ratio of the Electricity production(% of total) of Netherlands in 2004 to that in 2005?
Your answer should be very brief. 1.06. What is the ratio of the Electricity production(% of total) of Bulgaria in 2004 to that in 2006?
Keep it short and to the point. 0.82. What is the ratio of the Electricity production(% of total) of Cambodia in 2004 to that in 2006?
Your answer should be very brief. 0.81. What is the ratio of the Electricity production(% of total) of Croatia in 2004 to that in 2006?
Make the answer very short. 1.08. What is the ratio of the Electricity production(% of total) of Netherlands in 2004 to that in 2006?
Keep it short and to the point. 0.86. What is the ratio of the Electricity production(% of total) in Bulgaria in 2004 to that in 2007?
Offer a terse response. 1.14. What is the ratio of the Electricity production(% of total) in Cambodia in 2004 to that in 2007?
Offer a terse response. 1.05. What is the ratio of the Electricity production(% of total) in Croatia in 2004 to that in 2007?
Your answer should be compact. 1.5. What is the ratio of the Electricity production(% of total) of Netherlands in 2004 to that in 2007?
Provide a short and direct response. 0.91. What is the ratio of the Electricity production(% of total) in Bulgaria in 2004 to that in 2008?
Provide a short and direct response. 1.21. What is the ratio of the Electricity production(% of total) in Cambodia in 2004 to that in 2008?
Provide a short and direct response. 1.14. What is the ratio of the Electricity production(% of total) of Croatia in 2004 to that in 2008?
Your answer should be very brief. 1.23. What is the ratio of the Electricity production(% of total) of Netherlands in 2004 to that in 2008?
Offer a terse response. 0.98. What is the ratio of the Electricity production(% of total) of Bulgaria in 2005 to that in 2006?
Ensure brevity in your answer.  1.06. What is the ratio of the Electricity production(% of total) in Cambodia in 2005 to that in 2006?
Your answer should be very brief. 1.12. What is the ratio of the Electricity production(% of total) of Croatia in 2005 to that in 2006?
Your response must be concise. 1.05. What is the ratio of the Electricity production(% of total) of Netherlands in 2005 to that in 2006?
Provide a succinct answer. 0.82. What is the ratio of the Electricity production(% of total) of Bulgaria in 2005 to that in 2007?
Give a very brief answer. 1.47. What is the ratio of the Electricity production(% of total) of Cambodia in 2005 to that in 2007?
Your answer should be very brief. 1.45. What is the ratio of the Electricity production(% of total) in Croatia in 2005 to that in 2007?
Your answer should be compact. 1.46. What is the ratio of the Electricity production(% of total) of Netherlands in 2005 to that in 2007?
Provide a short and direct response. 0.86. What is the ratio of the Electricity production(% of total) of Bulgaria in 2005 to that in 2008?
Offer a very short reply. 1.56. What is the ratio of the Electricity production(% of total) in Cambodia in 2005 to that in 2008?
Give a very brief answer. 1.57. What is the ratio of the Electricity production(% of total) in Croatia in 2005 to that in 2008?
Ensure brevity in your answer.  1.2. What is the ratio of the Electricity production(% of total) in Netherlands in 2005 to that in 2008?
Your answer should be very brief. 0.93. What is the ratio of the Electricity production(% of total) in Bulgaria in 2006 to that in 2007?
Keep it short and to the point. 1.39. What is the ratio of the Electricity production(% of total) in Cambodia in 2006 to that in 2007?
Your answer should be very brief. 1.29. What is the ratio of the Electricity production(% of total) in Croatia in 2006 to that in 2007?
Ensure brevity in your answer.  1.39. What is the ratio of the Electricity production(% of total) of Netherlands in 2006 to that in 2007?
Your response must be concise. 1.06. What is the ratio of the Electricity production(% of total) of Bulgaria in 2006 to that in 2008?
Offer a very short reply. 1.47. What is the ratio of the Electricity production(% of total) of Cambodia in 2006 to that in 2008?
Provide a succinct answer. 1.4. What is the ratio of the Electricity production(% of total) of Croatia in 2006 to that in 2008?
Your answer should be very brief. 1.14. What is the ratio of the Electricity production(% of total) in Netherlands in 2006 to that in 2008?
Keep it short and to the point. 1.14. What is the ratio of the Electricity production(% of total) in Bulgaria in 2007 to that in 2008?
Make the answer very short. 1.06. What is the ratio of the Electricity production(% of total) in Cambodia in 2007 to that in 2008?
Your answer should be compact. 1.09. What is the ratio of the Electricity production(% of total) of Croatia in 2007 to that in 2008?
Make the answer very short. 0.82. What is the ratio of the Electricity production(% of total) of Netherlands in 2007 to that in 2008?
Ensure brevity in your answer.  1.07. What is the difference between the highest and the second highest Electricity production(% of total) of Bulgaria?
Make the answer very short. 0.55. What is the difference between the highest and the second highest Electricity production(% of total) of Cambodia?
Keep it short and to the point. 0.81. What is the difference between the highest and the second highest Electricity production(% of total) of Croatia?
Make the answer very short. 1.34. What is the difference between the highest and the second highest Electricity production(% of total) in Netherlands?
Ensure brevity in your answer.  0.01. What is the difference between the highest and the lowest Electricity production(% of total) in Bulgaria?
Provide a short and direct response. 4.66. What is the difference between the highest and the lowest Electricity production(% of total) of Cambodia?
Offer a terse response. 2.47. What is the difference between the highest and the lowest Electricity production(% of total) in Croatia?
Keep it short and to the point. 17.54. What is the difference between the highest and the lowest Electricity production(% of total) of Netherlands?
Make the answer very short. 0.04. 